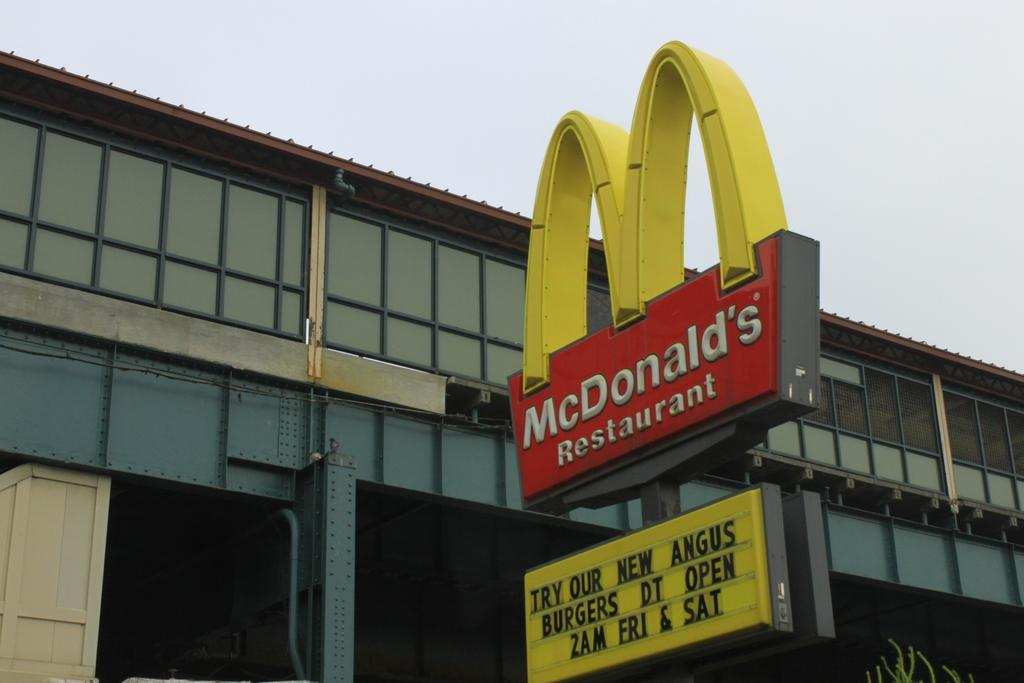What is located on the pole in the image? There is an advertise board on a pole in the image. Where is the advertise board positioned in relation to the image? The advertise board is at the bottom of the image. What can be seen in the background of the image? There is a building in the background of the image. What is visible at the top of the image? The sky is visible at the top of the image. How many clocks are running in the image? There are no clocks visible in the image, so it is not possible to determine how many are running. 